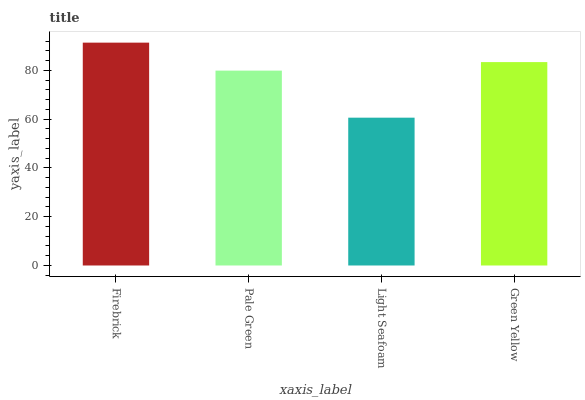Is Light Seafoam the minimum?
Answer yes or no. Yes. Is Firebrick the maximum?
Answer yes or no. Yes. Is Pale Green the minimum?
Answer yes or no. No. Is Pale Green the maximum?
Answer yes or no. No. Is Firebrick greater than Pale Green?
Answer yes or no. Yes. Is Pale Green less than Firebrick?
Answer yes or no. Yes. Is Pale Green greater than Firebrick?
Answer yes or no. No. Is Firebrick less than Pale Green?
Answer yes or no. No. Is Green Yellow the high median?
Answer yes or no. Yes. Is Pale Green the low median?
Answer yes or no. Yes. Is Firebrick the high median?
Answer yes or no. No. Is Green Yellow the low median?
Answer yes or no. No. 